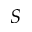<formula> <loc_0><loc_0><loc_500><loc_500>S</formula> 